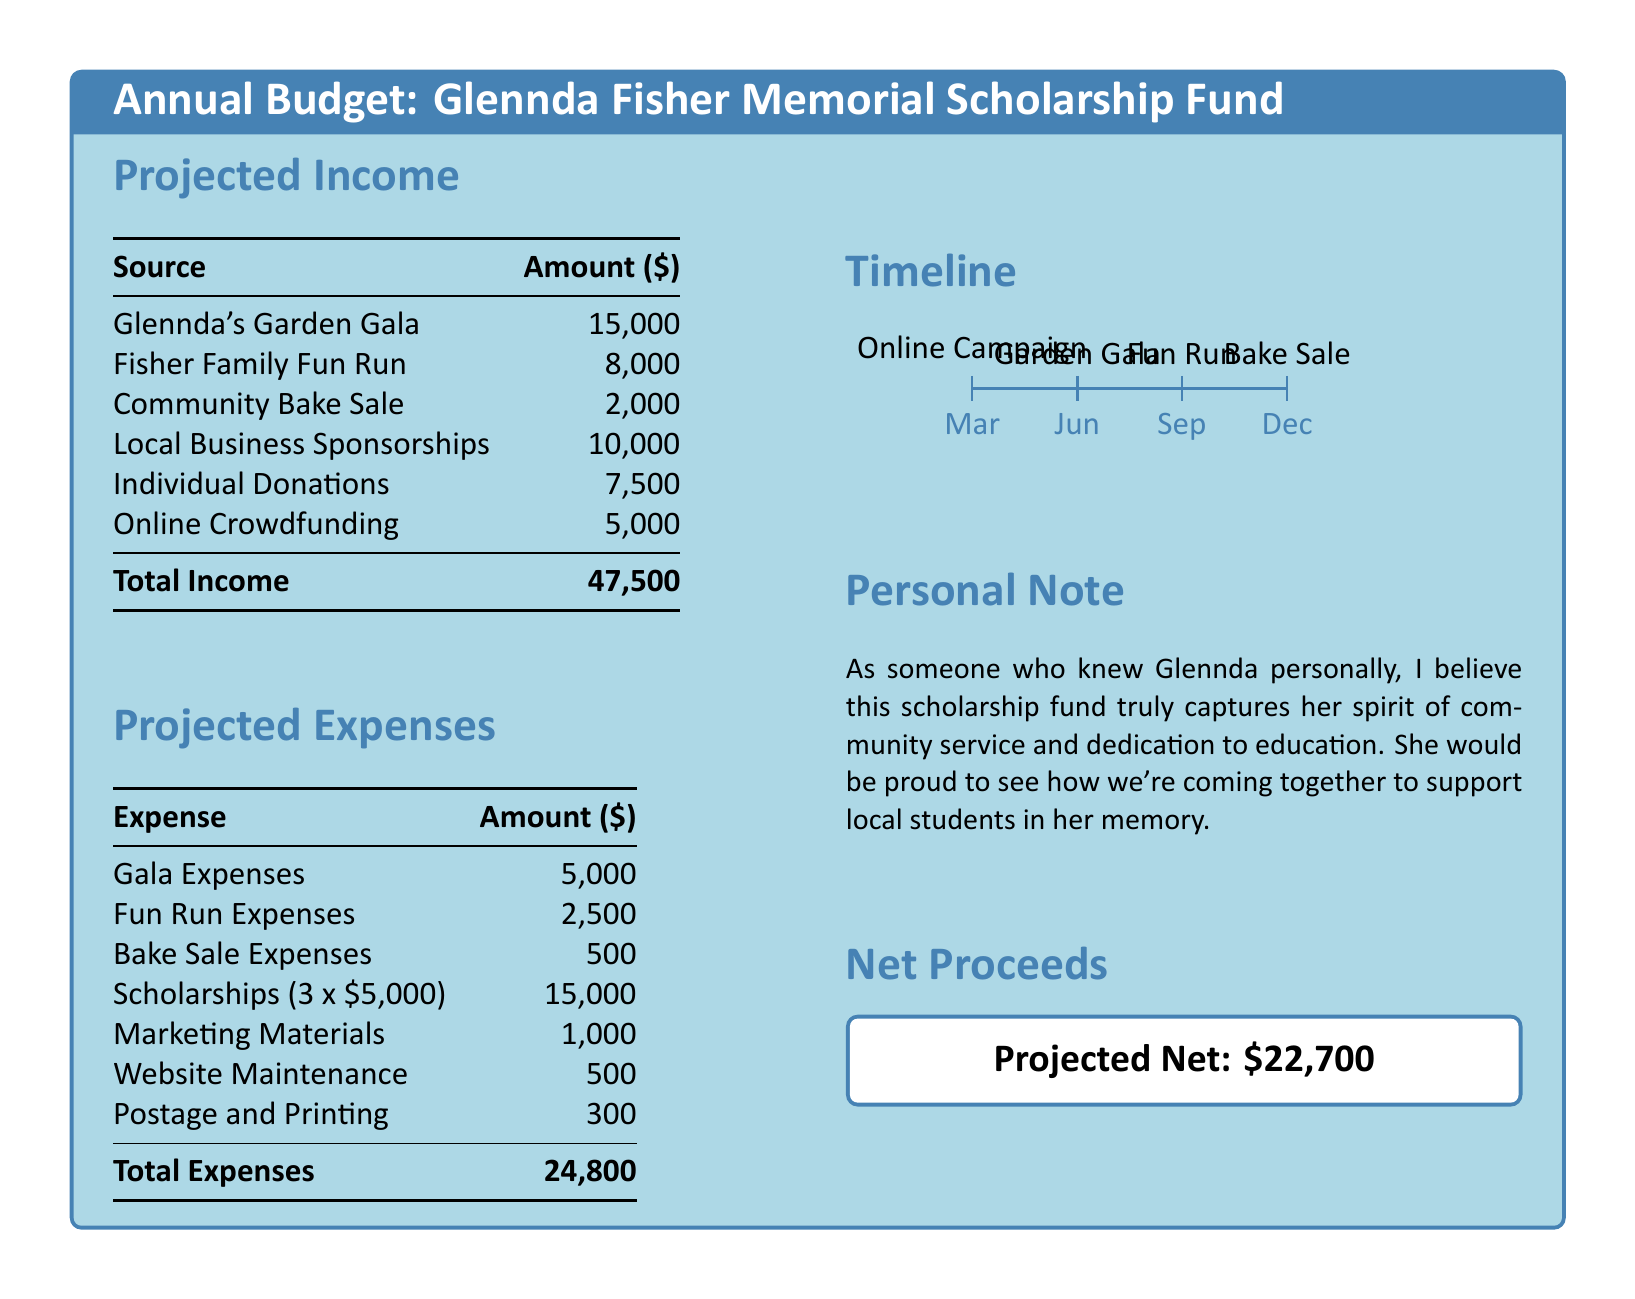What is the total projected income? The total projected income is the sum of all income sources listed in the document, which equals $15,000 + $8,000 + $2,000 + $10,000 + $7,500 + $5,000.
Answer: $47,500 How much is allocated for scholarships? The document specifies that the scholarship expense is for three scholarships of $5,000 each, totaling $15,000.
Answer: $15,000 What is the expense for the Fun Run? The document lists the expenses for the Fun Run, which is detailed separately.
Answer: $2,500 What are the marketing materials expenses? The document specifies the amount allocated for marketing materials.
Answer: $1,000 What is the net projected proceeds? The net projected proceeds are calculated from the total income minus total expenses in the document.
Answer: $22,700 When is the Garden Gala scheduled? The document timeline indicates the timing for events; the Garden Gala is scheduled for June.
Answer: June What is the total amount spent on fundraising expenses? The total amount spent on all fundraising expenses is detailed in the expenses section.
Answer: $8,000 How many sources of income are listed? The document outlines the sources of income and counts them for an accurate total.
Answer: 6 What is the expense for the Bake Sale? The document specifies how much will be spent on the Bake Sale as its own line item.
Answer: $500 What does the personal note emphasize about Glennda? The personal note highlights the values that Glennda represented in her community service and dedication.
Answer: Community service and dedication 